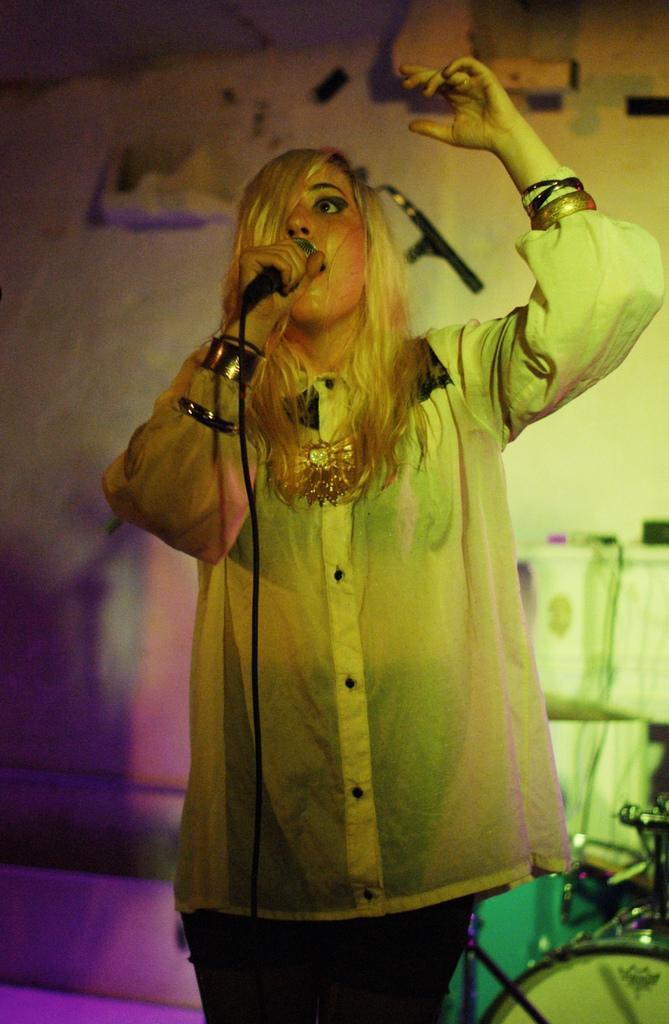Can you describe this image briefly? In the given image i can see a lady holding a mike and singing. 